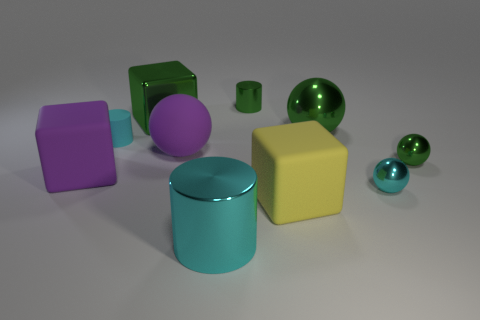Are there any other things that have the same shape as the small cyan rubber object?
Offer a terse response. Yes. What number of metallic things are either green balls or large blue blocks?
Give a very brief answer. 2. Is the number of tiny cyan matte objects behind the big green sphere less than the number of gray cylinders?
Offer a very short reply. No. There is a big rubber thing to the left of the large purple thing that is right of the green thing that is left of the large purple sphere; what is its shape?
Your answer should be compact. Cube. Do the rubber cylinder and the large metallic cylinder have the same color?
Provide a succinct answer. Yes. Is the number of green metallic cylinders greater than the number of small purple rubber balls?
Provide a succinct answer. Yes. What number of other things are made of the same material as the small green ball?
Ensure brevity in your answer.  5. How many things are tiny cyan things or cyan things in front of the cyan rubber object?
Your answer should be very brief. 3. Are there fewer cylinders than green shiny objects?
Provide a succinct answer. Yes. The sphere in front of the big rubber object to the left of the big green metal object that is left of the big shiny cylinder is what color?
Offer a terse response. Cyan. 